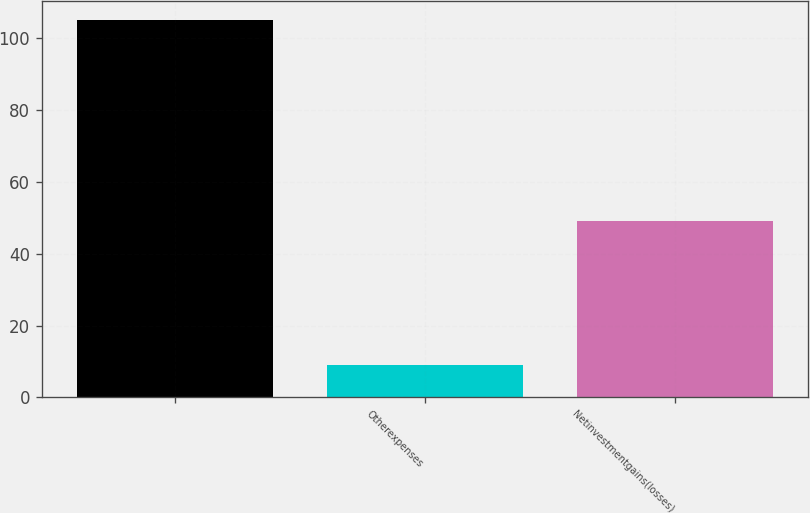<chart> <loc_0><loc_0><loc_500><loc_500><bar_chart><ecel><fcel>Otherexpenses<fcel>Netinvestmentgains(losses)<nl><fcel>105<fcel>9<fcel>49<nl></chart> 